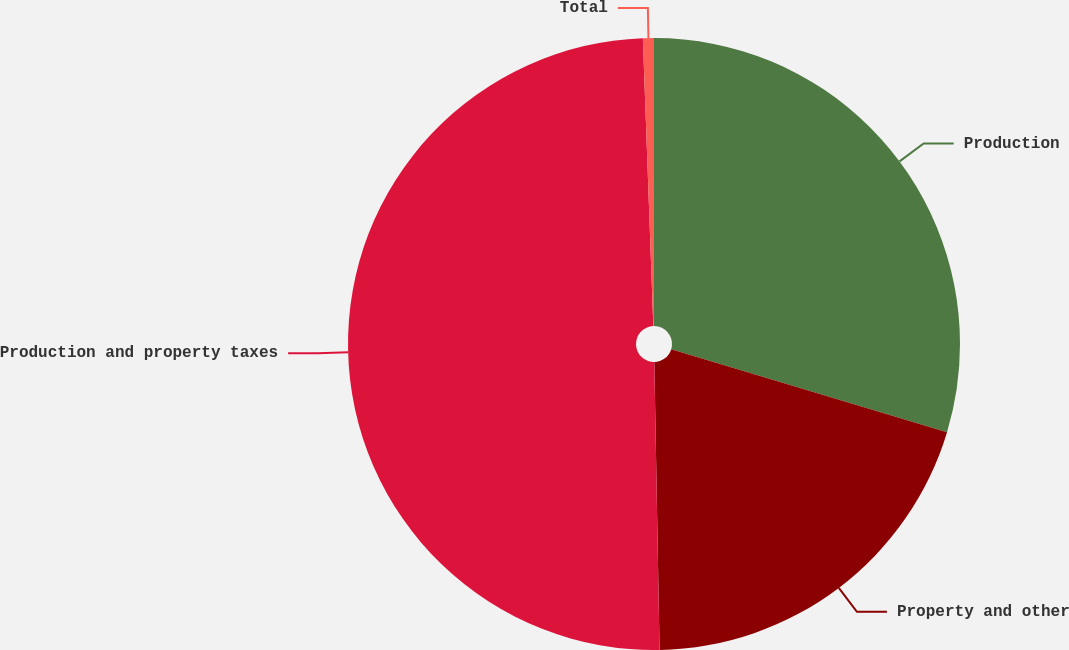<chart> <loc_0><loc_0><loc_500><loc_500><pie_chart><fcel>Production<fcel>Property and other<fcel>Production and property taxes<fcel>Total<nl><fcel>29.65%<fcel>20.06%<fcel>49.71%<fcel>0.58%<nl></chart> 